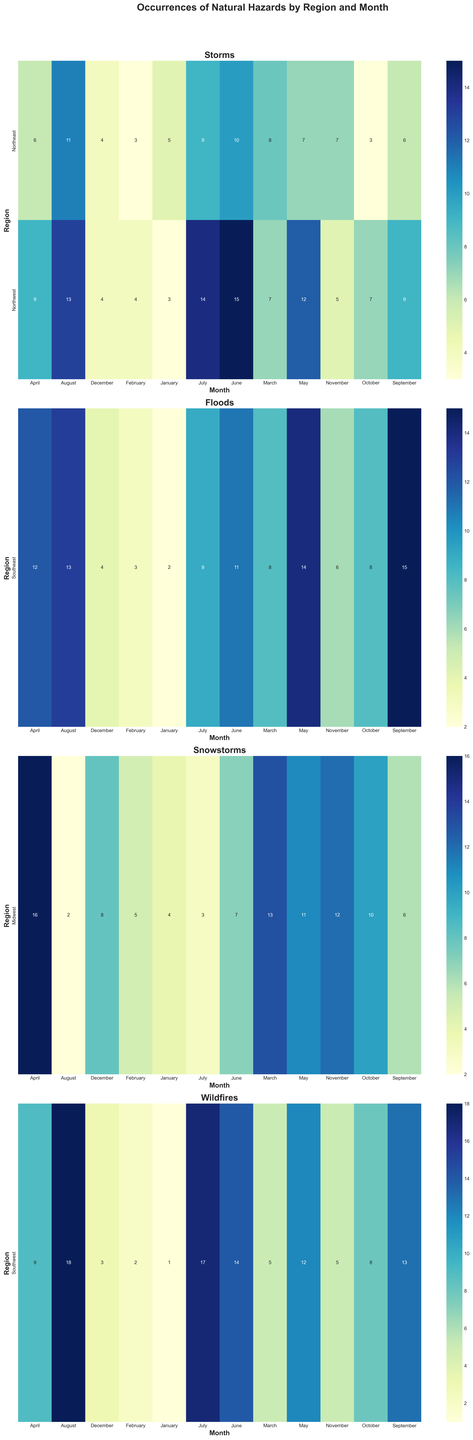Which region experiences the most wildfires in August? To find the region with the most wildfires in August, locate the "wildfires" heatmap, look for the August column, and identify the row with the highest value.
Answer: Southwest Which month has the highest number of floods in the Southeast? To determine the peak month for floods in the Southeast, check the "floods" heatmap, find the Southeast row, and identify the month with the highest value.
Answer: September Compare the occurrences of snowstorms in the Midwest between March and July. Which month has more? Locate the Midwest row in the "snowstorms" heatmap. Observe the values in March and July columns and compare them.
Answer: March What's the sum of storms in the Northeast from January to March? Sum the occurrences of storms in the months of January (5), February (3), and March (8) in the Northeast row of the "storms" heatmap.
Answer: 16 Which region has the least number of natural hazard cases in June? Compare the June values across all regions and natural hazards in their respective heatmaps, identifying the lowest value.
Answer: Midwest By how much do wildfires in May increase in the Southwest compared to April? Find the values for wildfires in April (9) and May (12) in the Southwest row, and calculate the difference.
Answer: 3 What's the average number of occurrences of storms in the Northwest over the entire year? Add up the occurrences of storms for each month in the Northwest row (3 + 4 + 7 + 9 + 12 + 15 + 14 + 13 + 9 + 7 + 5 + 4 = 102) and divide by 12.
Answer: 8.5 Which hazard shows the highest growth over the summer months (June to August)? For each hazard, calculate the sum of occurrences in June, July, and August, finding which hazard has the largest total.
Answer: Wildfires Compare the color intensity for snowstorms in the Midwest between November and May. Which month appears darker? Visually compare the color shades for snowstorms in the Midwest between November and May. The darker shade indicates a higher occurrence.
Answer: November In which month do storms in the Northeast peak, and what is their occurrence value? Identify the highest value in the Northeast row within the "storms" heatmap and note the corresponding month and value.
Answer: August, 11 